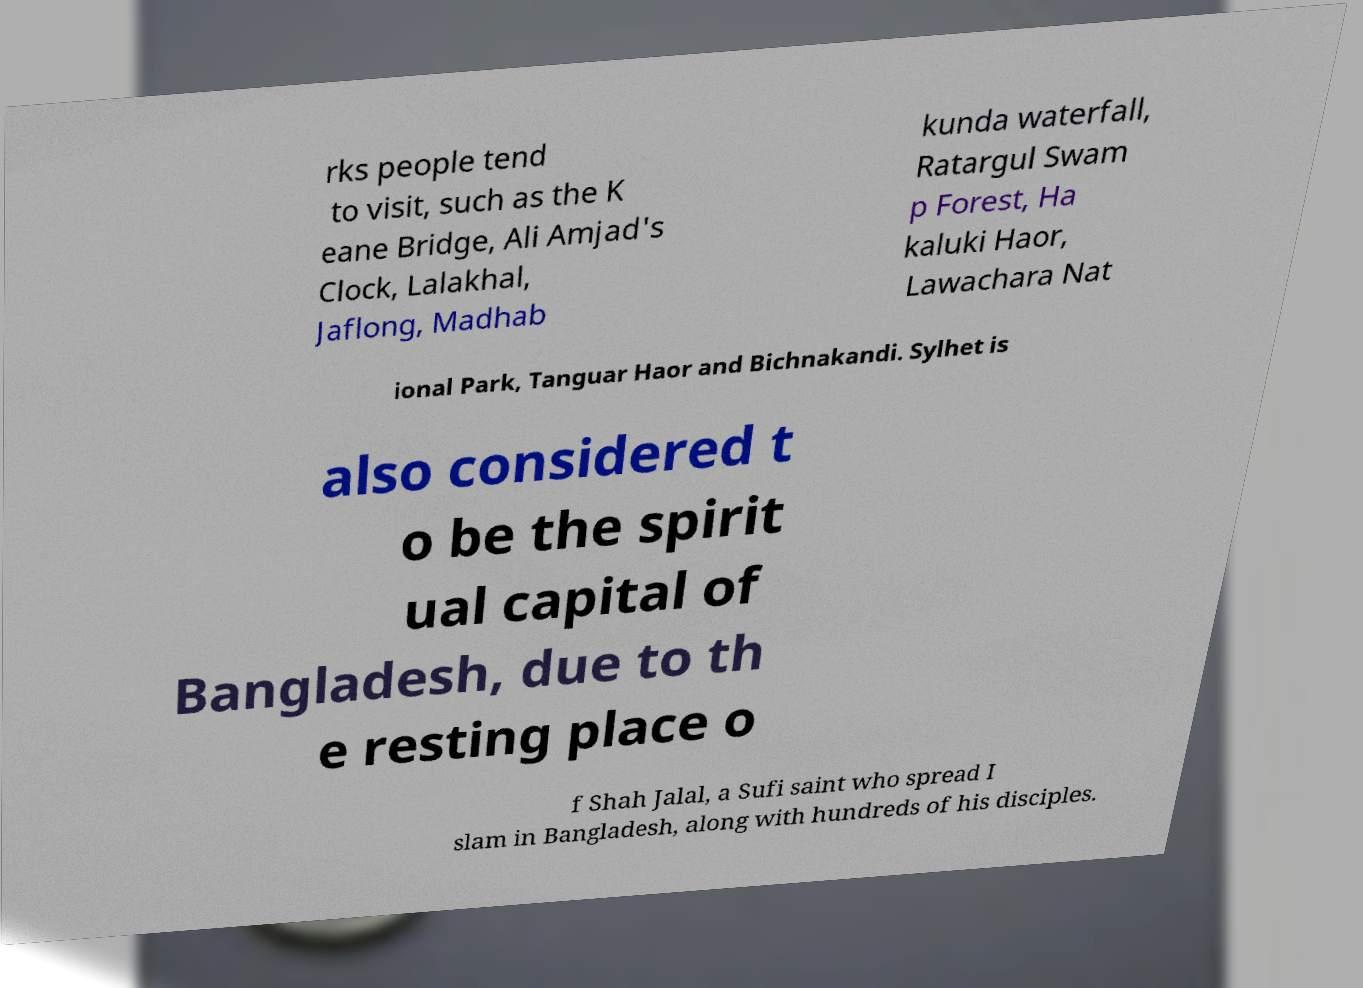For documentation purposes, I need the text within this image transcribed. Could you provide that? rks people tend to visit, such as the K eane Bridge, Ali Amjad's Clock, Lalakhal, Jaflong, Madhab kunda waterfall, Ratargul Swam p Forest, Ha kaluki Haor, Lawachara Nat ional Park, Tanguar Haor and Bichnakandi. Sylhet is also considered t o be the spirit ual capital of Bangladesh, due to th e resting place o f Shah Jalal, a Sufi saint who spread I slam in Bangladesh, along with hundreds of his disciples. 